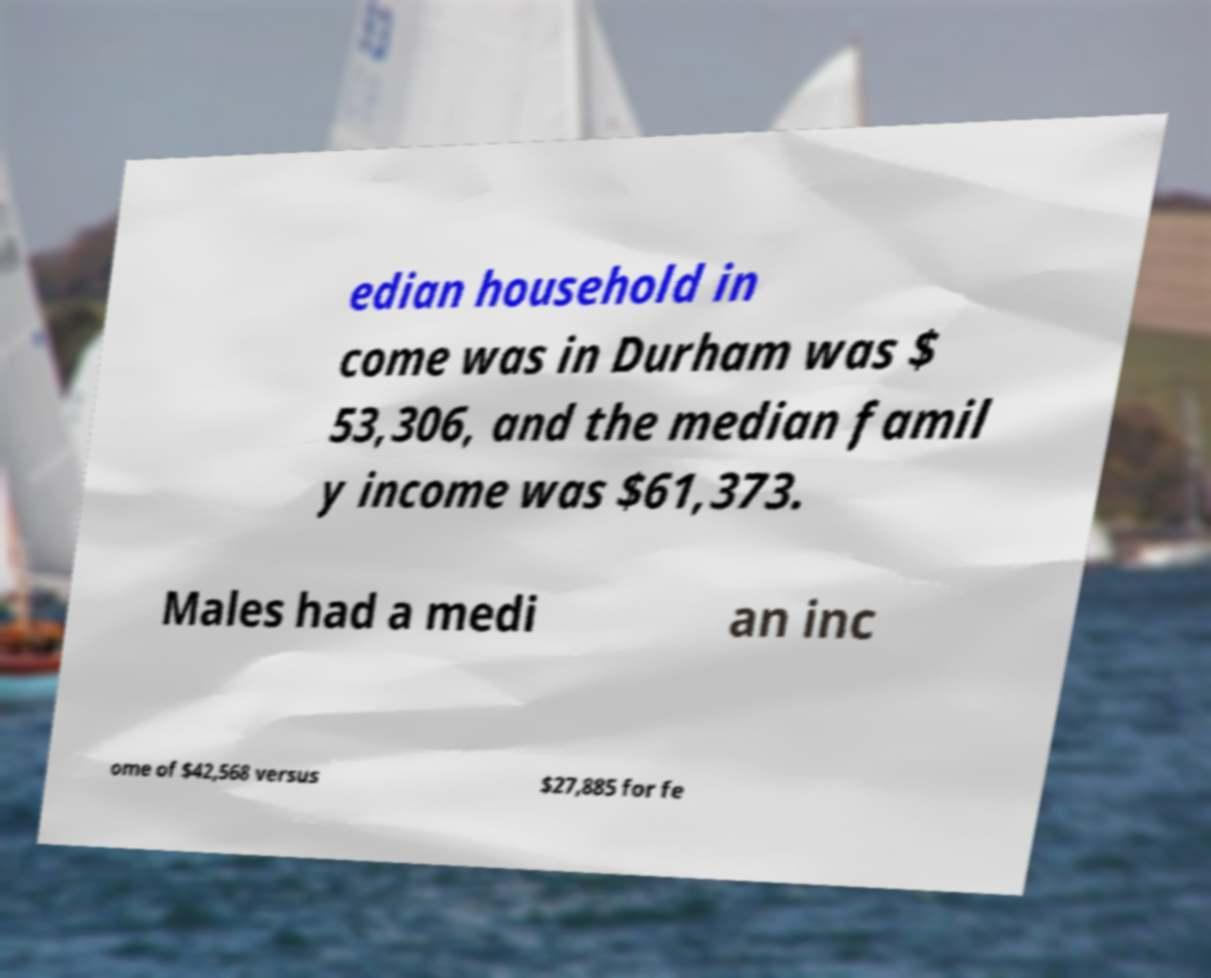Could you assist in decoding the text presented in this image and type it out clearly? edian household in come was in Durham was $ 53,306, and the median famil y income was $61,373. Males had a medi an inc ome of $42,568 versus $27,885 for fe 